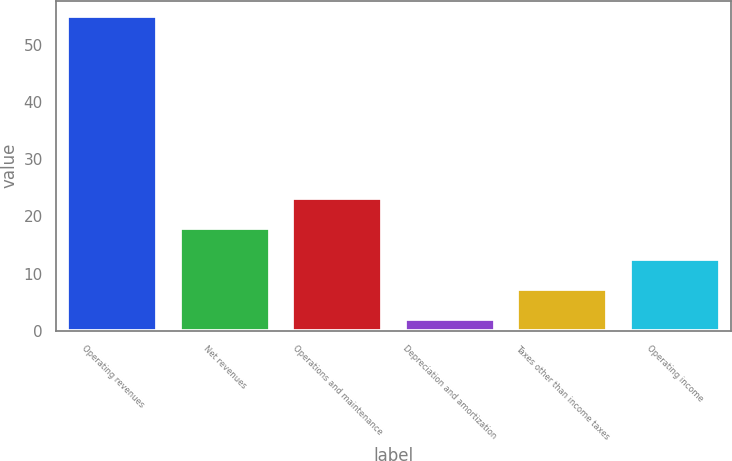Convert chart to OTSL. <chart><loc_0><loc_0><loc_500><loc_500><bar_chart><fcel>Operating revenues<fcel>Net revenues<fcel>Operations and maintenance<fcel>Depreciation and amortization<fcel>Taxes other than income taxes<fcel>Operating income<nl><fcel>55<fcel>17.9<fcel>23.2<fcel>2<fcel>7.3<fcel>12.6<nl></chart> 